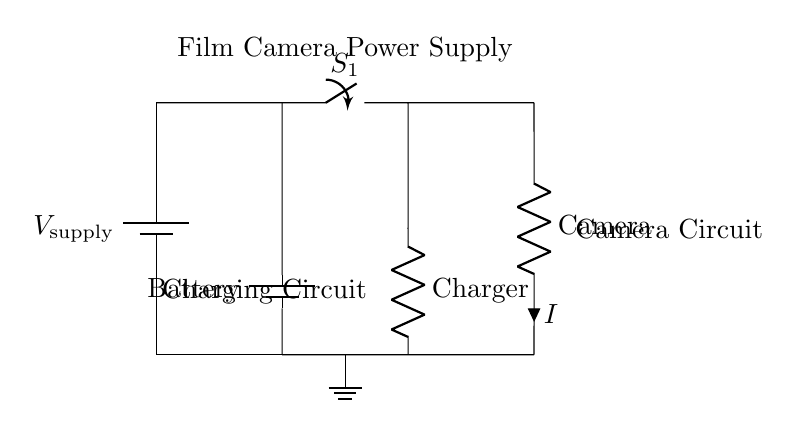What is the power supply voltage? The power supply voltage is indicated as \( V_{\text{supply}} \), which can be read directly from the labeling in the circuit.
Answer: V_supply What components are in the charging circuit? The charging circuit consists of a resistor labeled as Charger, which is connected to the output of the power supply and the battery. The resistor's role is to limit current while charging.
Answer: Charger What is the current flowing through the camera circuit labeled as? The current flowing through the camera circuit is labeled as \( I \), which is indicated next to the resistor in the camera circuit. This shows the flow of current through the camera component.
Answer: I What happens when switch S1 is open? When switch S1 is open, there will be no current flow in the circuit section that includes the camera, therefore the camera will not operate. This is a direct consequence of having an open switch in a series circuit, as it breaks the circuit.
Answer: No current Which component connects directly to the battery? The battery connects directly to the resistor in the camera circuit at one end and also connects to the charging circuit at the other end, forming a crucial path for both power and charging.
Answer: Battery What is the role of the resistor in the camera circuit? The resistor in the camera circuit limits the current flowing to the camera to ensure it operates within safe limits, preventing damage from excessive current. This shows careful design for protection of the camera equipment.
Answer: Limits current 